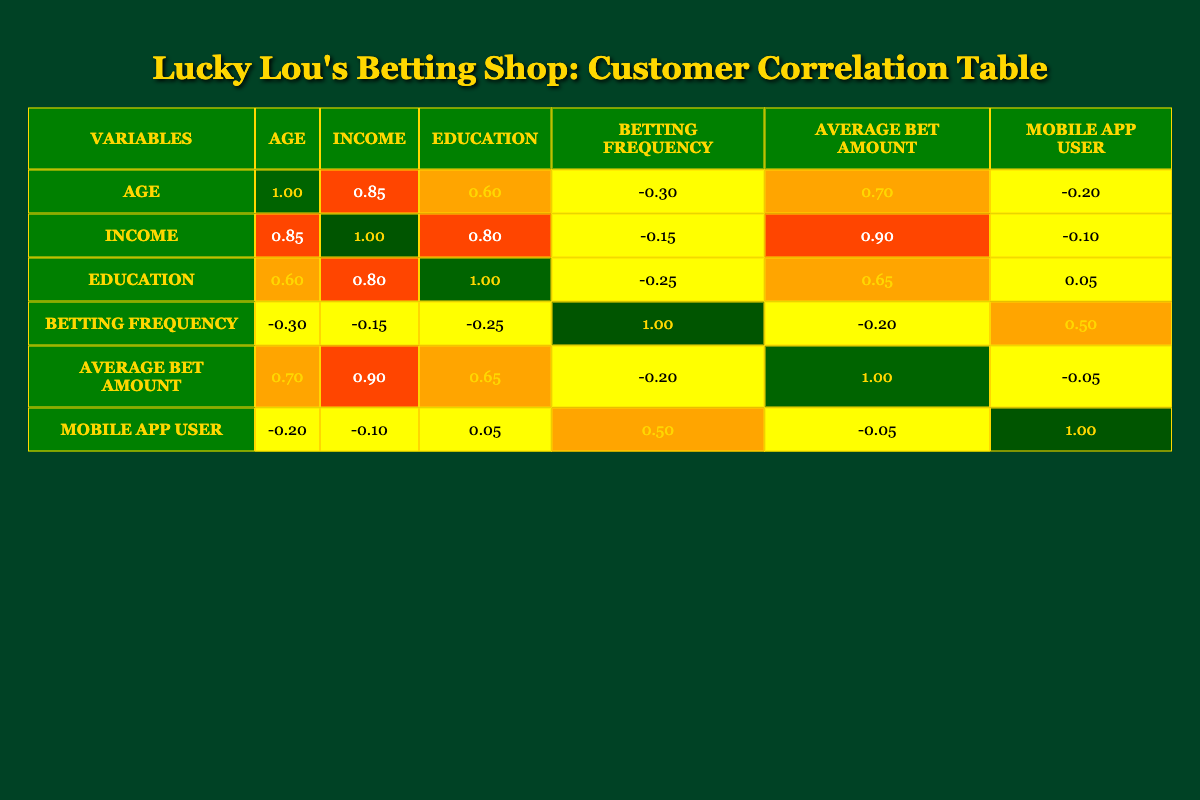What is the correlation between age and income? The table shows a correlation of 0.85 between age and income, indicating a strong positive relationship, meaning that as age increases, income tends to increase as well.
Answer: 0.85 How does education correlate with average bet amount? The correlation between education and average bet amount is 0.65, suggesting that higher levels of education are associated with higher average bet amounts.
Answer: 0.65 Is there a correlation between betting frequency and mobile app usage? The correlation between betting frequency and mobile app usage is 0.50, indicating a moderate positive relationship; those who bet more frequently are somewhat more likely to be mobile app users.
Answer: Yes What is the average correlation score for age with other variables? To find the average correlation score for age with the other variables, we take the correlations with income (0.85), education (0.60), betting frequency (-0.30), average bet amount (0.70), and mobile app user (-0.20). Summing these gives 0.85 + 0.60 - 0.30 + 0.70 - 0.20 = 1.65, and dividing by 5 gives an average of 0.33.
Answer: 0.33 Is it true that the average bet amount has a high correlation with income? The correlation between average bet amount and income is 0.90, which is classified as a high correlation, indicating that higher incomes tend to correlate with higher average bet amounts.
Answer: True What is the lowest correlation score in the table? The lowest correlation score is -0.30, which is between age and betting frequency, highlighting a weak negative relationship, meaning increased age is weakly associated with less frequent betting.
Answer: -0.30 How many variables exhibit a high correlation with average bet amount? The average bet amount has high correlations with income (0.90) and age (0.70), making a total of 2 variables with high correlation (above 0.70).
Answer: 2 Does gender have any correlation with betting frequency? The table does not include correlation values associated specifically with gender; hence we cannot determine if there is a correlation without further data.
Answer: No What would the correlation matrix look like if we only considered mobile app users? Since the table does not provide a correlation specifically for mobile app users, we cannot extract or hypothesize a new correlation matrix based solely on this subgroup from the existing data.
Answer: Cannot determine 